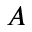<formula> <loc_0><loc_0><loc_500><loc_500>A</formula> 